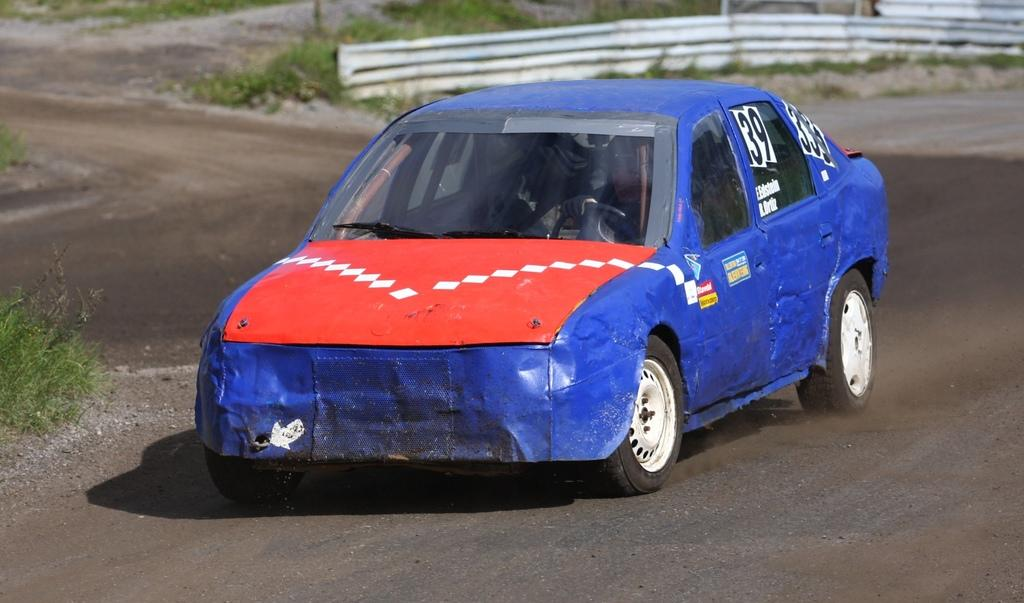What is the main subject of the image? The main subject of the image is a race car. What colors can be seen on the race car? The race car has blue and red colors. Where is the race car located in the image? The race car is on the road. What can be seen in the background of the image? There are plants and iron sheets in the background of the image. How many toys are being used to help the race car in the image? There are no toys present in the image, and the race car does not require any assistance. 